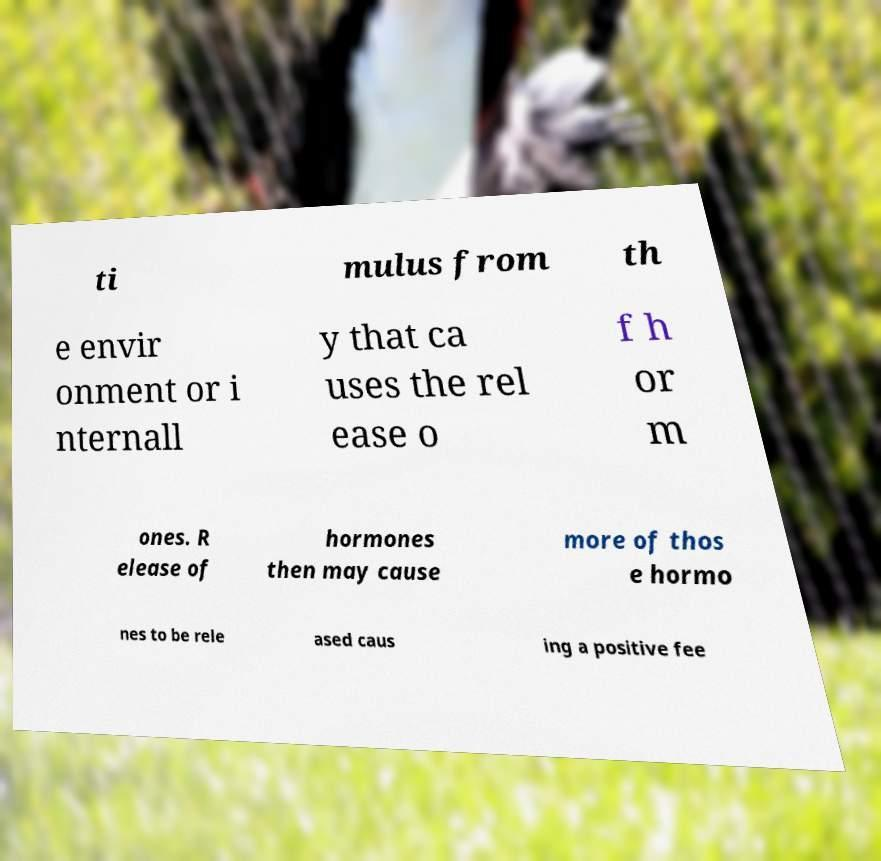There's text embedded in this image that I need extracted. Can you transcribe it verbatim? ti mulus from th e envir onment or i nternall y that ca uses the rel ease o f h or m ones. R elease of hormones then may cause more of thos e hormo nes to be rele ased caus ing a positive fee 